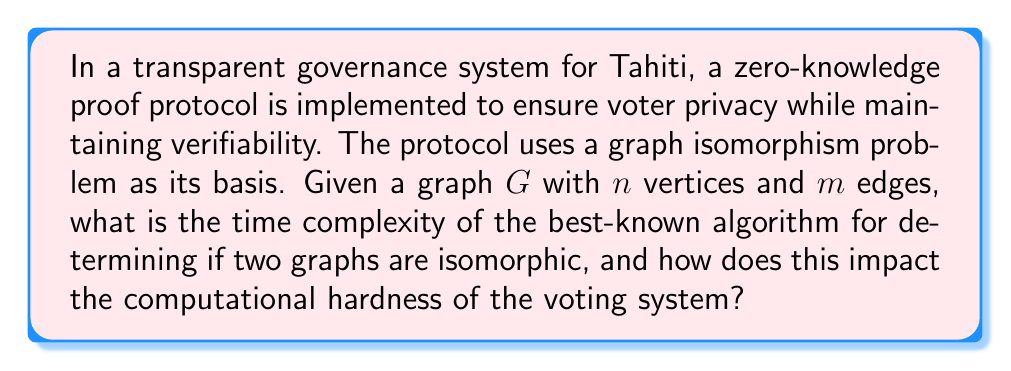Give your solution to this math problem. To analyze the computational hardness of this cryptographic protocol, we need to consider the complexity of the graph isomorphism problem:

1. Graph Isomorphism Problem:
   The best-known algorithm for graph isomorphism is Babai's quasipolynomial-time algorithm.

2. Time Complexity:
   Babai's algorithm has a time complexity of:
   
   $$O(exp((log n)^c))$$
   
   where $c$ is a constant, approximately $c \approx 3$.

3. Comparison to Polynomial Time:
   This is faster than exponential time but slower than polynomial time:
   
   $$O(n^k) < O(exp((log n)^c)) < O(2^n)$$
   
   for any constant $k$ and sufficiently large $n$.

4. Impact on Voting System:
   a) Security: The quasipolynomial-time complexity provides a good balance between security and efficiency.
   b) Scalability: As the number of voters ($n$) increases, the system remains computationally feasible.
   c) Transparency: The well-studied nature of graph isomorphism allows for public scrutiny of the protocol.

5. Tahitian Context:
   For Tahiti's population (approximately 280,000):
   
   $$n \approx 280,000$$
   $$log n \approx 18.15$$
   
   The complexity would be approximately:
   
   $$O(exp((18.15)^3)) \approx O(exp(5968))$$

   This is computationally hard but still feasible with modern computing power.

6. Fair Governance Implications:
   The protocol ensures voter privacy while allowing for verification, supporting the principles of fair and transparent governance valued in Tahitian political activism.
Answer: The time complexity of the best-known algorithm for graph isomorphism is quasipolynomial, specifically $O(exp((log n)^c))$ where $c \approx 3$. This provides a good balance of security and efficiency for the voting system, ensuring computational hardness while remaining feasible for Tahiti's population size, thus supporting fair and transparent governance. 